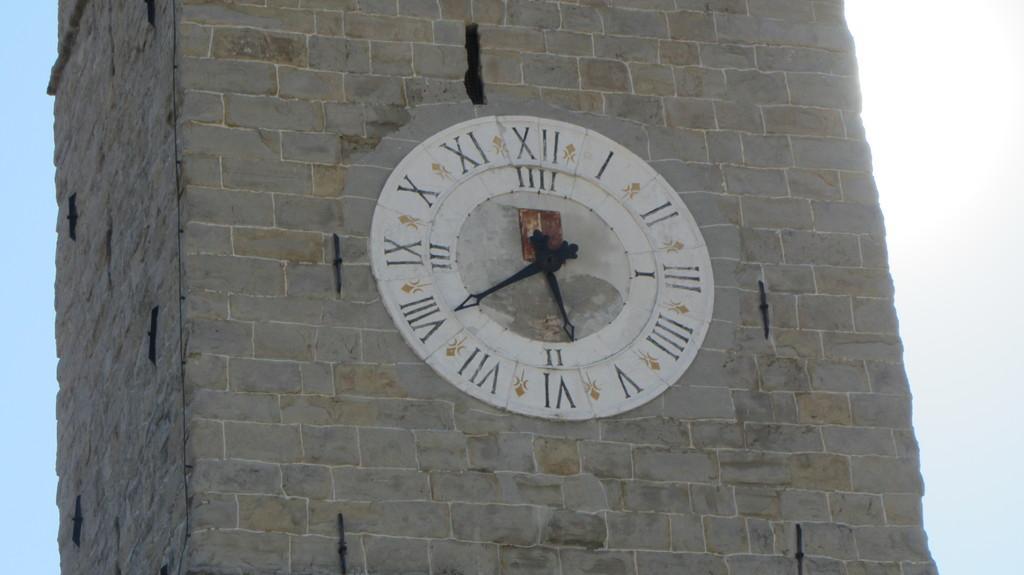Describe this image in one or two sentences. In this image we can see the rock wall. In the middle there is a clock. There is a sky. 